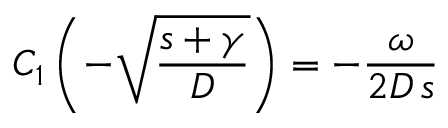Convert formula to latex. <formula><loc_0><loc_0><loc_500><loc_500>C _ { 1 } \left ( - \sqrt { \frac { s + \gamma } { D } } \right ) = - \frac { \omega } { 2 D \, s }</formula> 